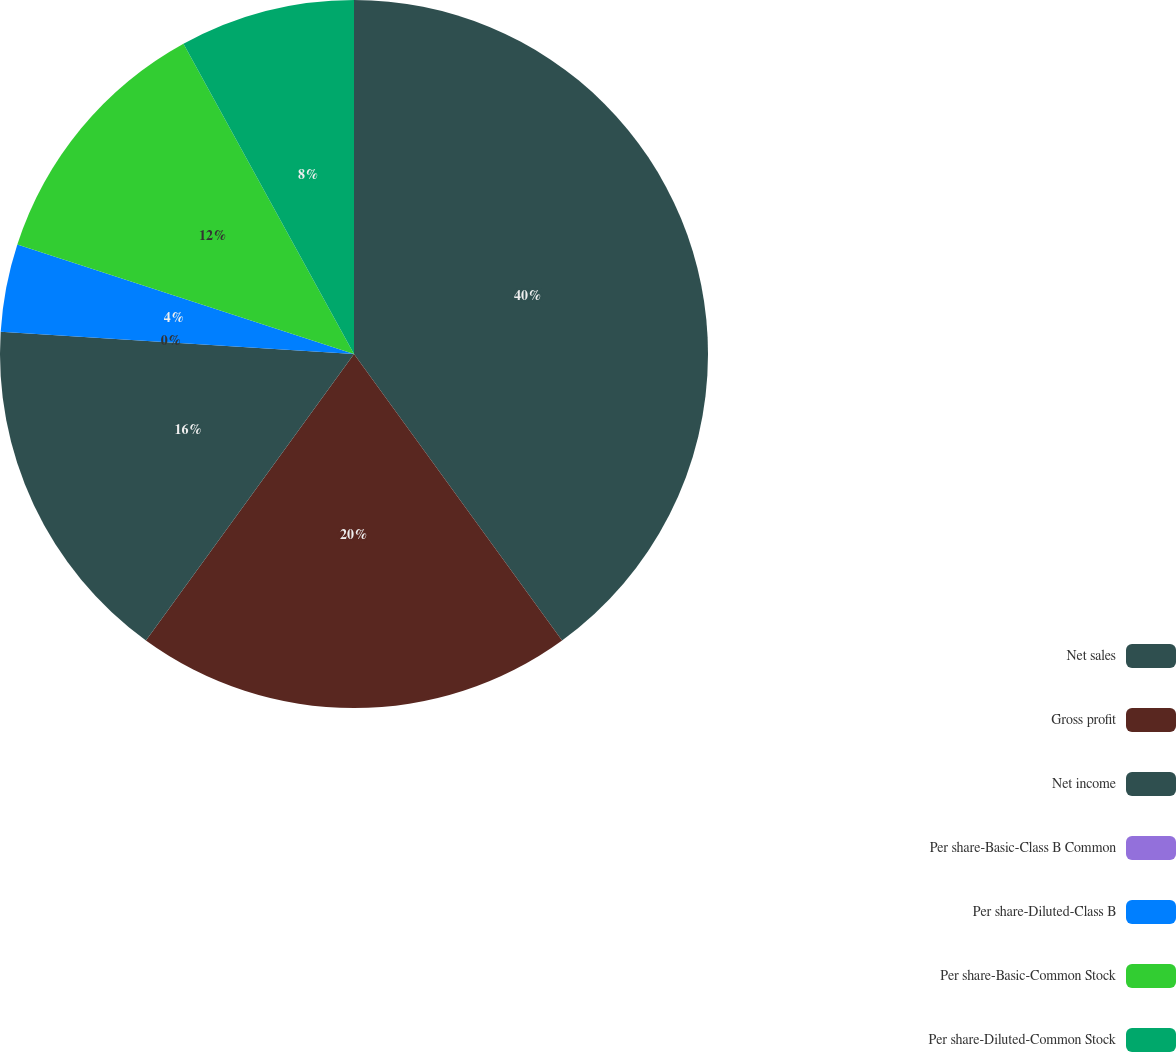Convert chart. <chart><loc_0><loc_0><loc_500><loc_500><pie_chart><fcel>Net sales<fcel>Gross profit<fcel>Net income<fcel>Per share-Basic-Class B Common<fcel>Per share-Diluted-Class B<fcel>Per share-Basic-Common Stock<fcel>Per share-Diluted-Common Stock<nl><fcel>40.0%<fcel>20.0%<fcel>16.0%<fcel>0.0%<fcel>4.0%<fcel>12.0%<fcel>8.0%<nl></chart> 